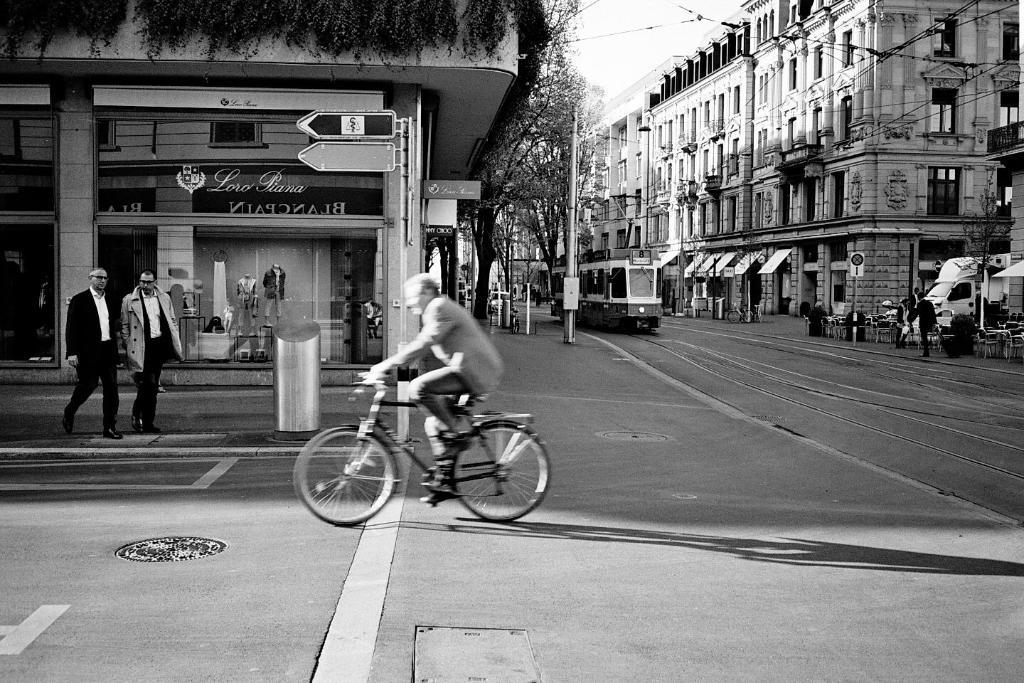What is the man in the image doing? The man is sitting on a bicycle in the image. What are the people in the image doing? People are walking on the road in the image. What structures can be seen in the image? There are buildings visible in the image. What type of vegetation is present in the image? There are trees in the image. Can you see the man's sister in the image? There is no mention of a sister in the image, so we cannot determine if she is present or not. 